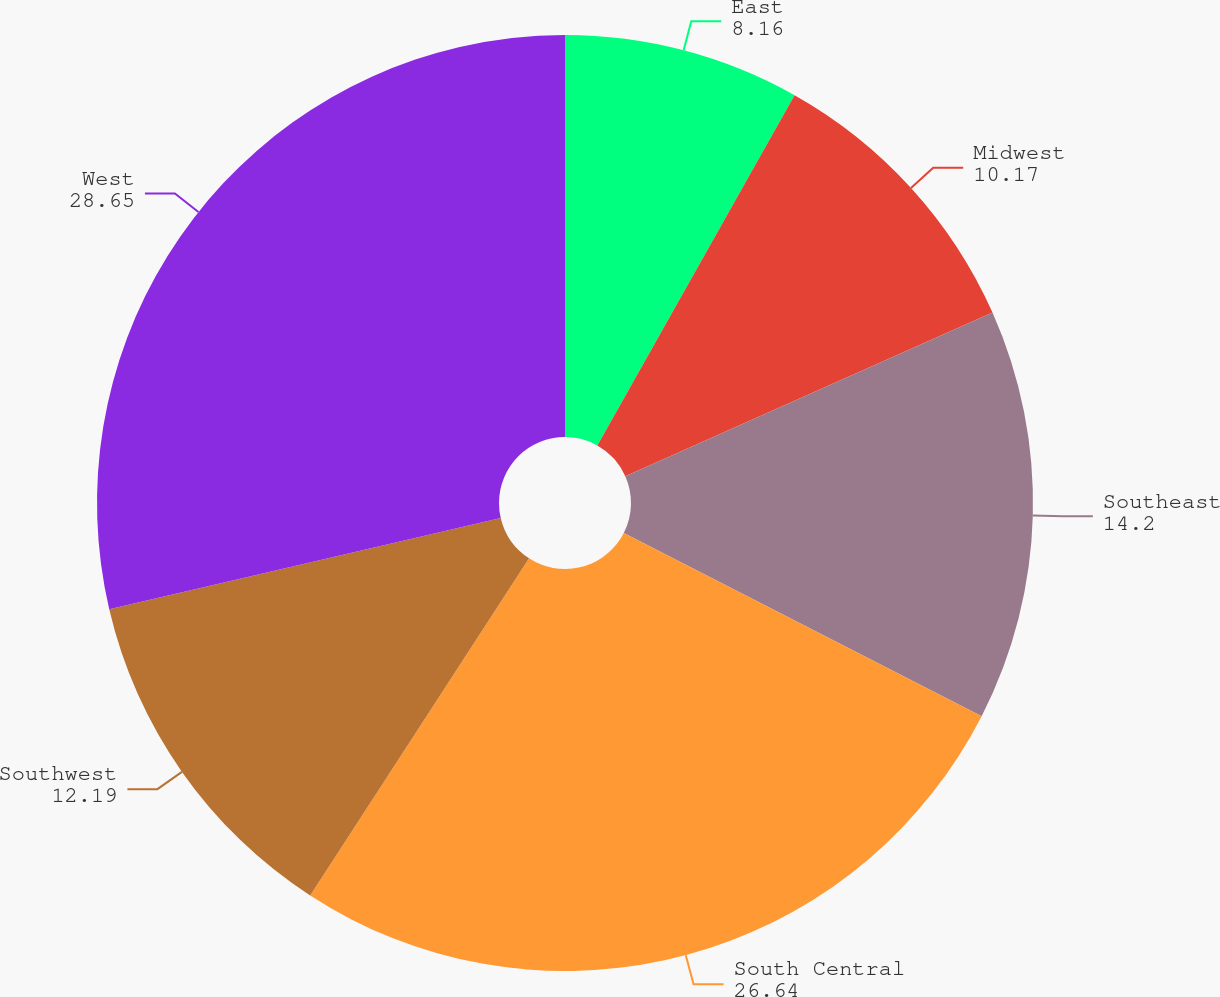<chart> <loc_0><loc_0><loc_500><loc_500><pie_chart><fcel>East<fcel>Midwest<fcel>Southeast<fcel>South Central<fcel>Southwest<fcel>West<nl><fcel>8.16%<fcel>10.17%<fcel>14.2%<fcel>26.64%<fcel>12.19%<fcel>28.65%<nl></chart> 